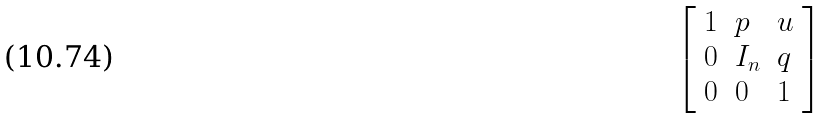<formula> <loc_0><loc_0><loc_500><loc_500>\left [ \begin{array} { l l l } { 1 } & { p } & { u } \\ { 0 } & { I _ { n } } & { q } \\ { 0 } & { 0 } & { 1 } \end{array} \right ]</formula> 